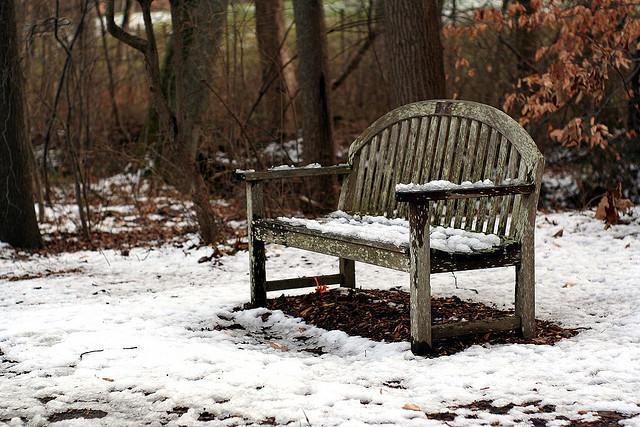How many people wears in green?
Give a very brief answer. 0. 